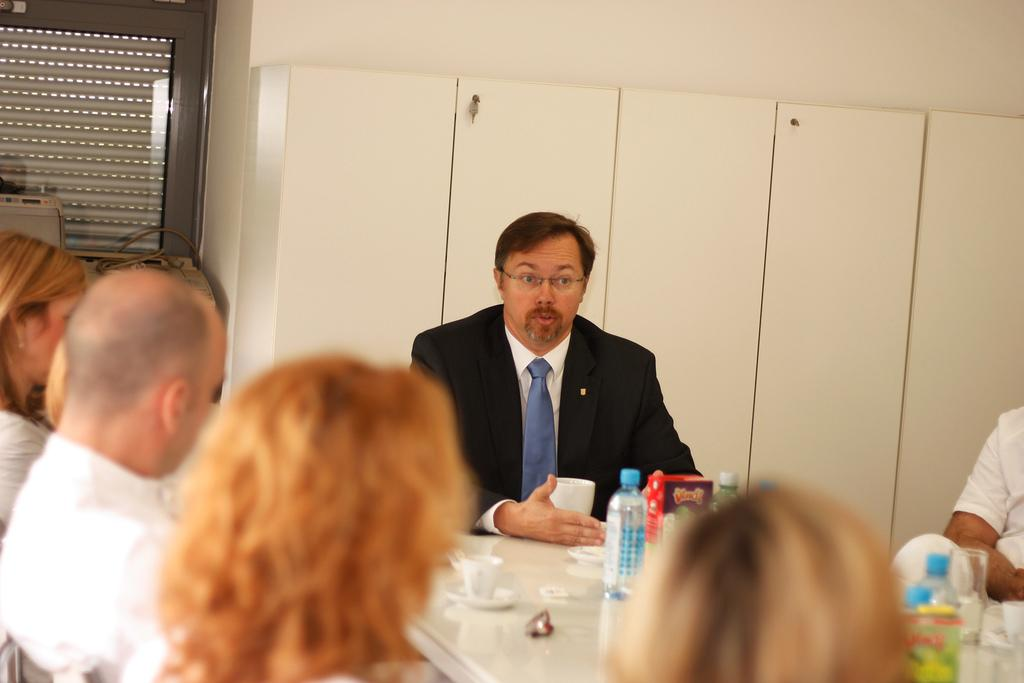What are the people in the image doing? There is a group of people sitting in the image. Can you describe the attire of one of the individuals? A man is wearing a suit in the image. What piece of furniture is present in the image? There is a table in the image. What is on the table? There is a cup and bottles on the table. Are there any other objects on the table? Yes, there are some objects on the table. What time is it according to the hour on the chalkboard in the image? There is no chalkboard or hour mentioned in the image; it only features a group of people sitting, a man in a suit, a table, a cup, bottles, and some objects. 